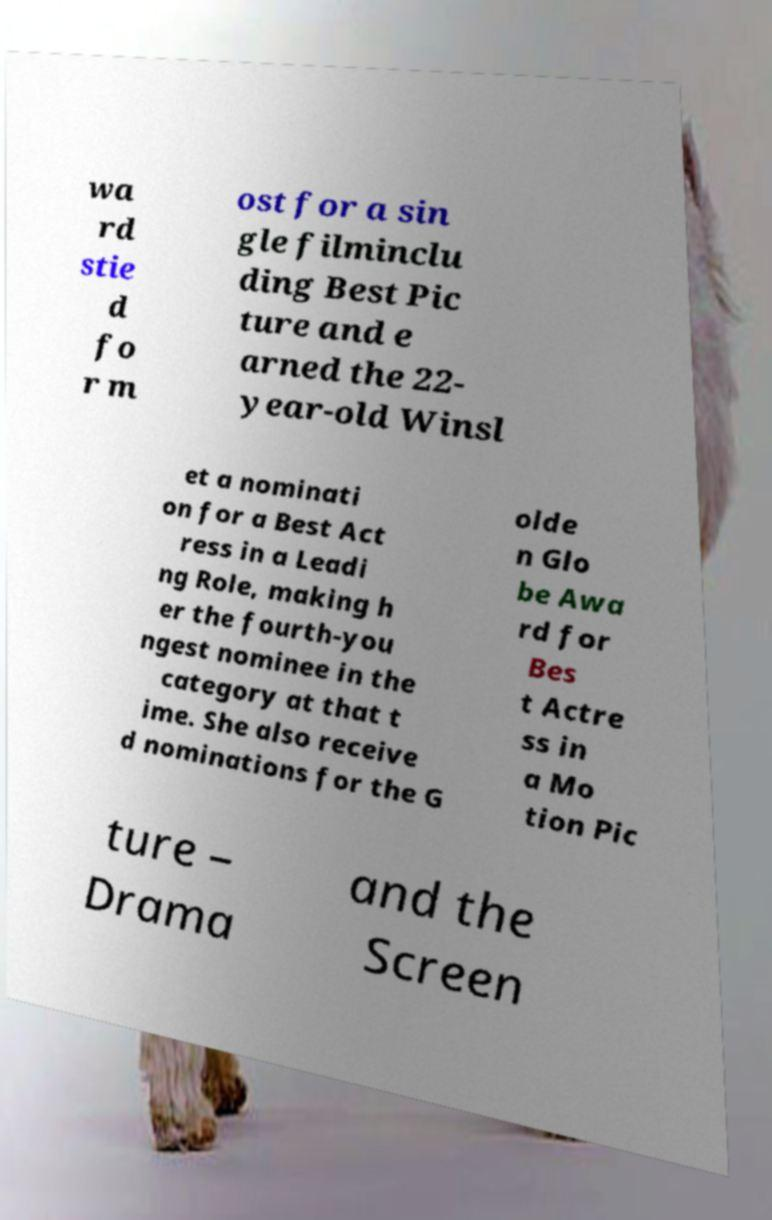What messages or text are displayed in this image? I need them in a readable, typed format. wa rd stie d fo r m ost for a sin gle filminclu ding Best Pic ture and e arned the 22- year-old Winsl et a nominati on for a Best Act ress in a Leadi ng Role, making h er the fourth-you ngest nominee in the category at that t ime. She also receive d nominations for the G olde n Glo be Awa rd for Bes t Actre ss in a Mo tion Pic ture – Drama and the Screen 